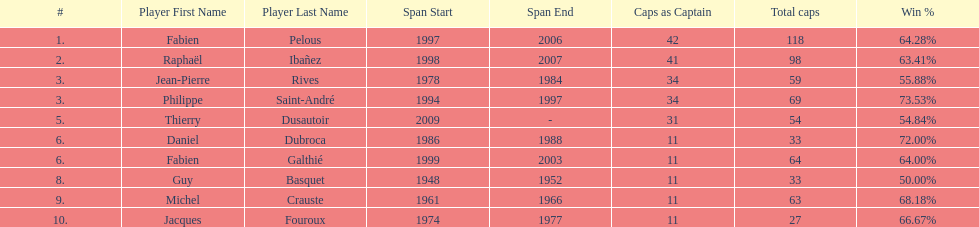How many caps did jean-pierre rives and michel crauste accrue? 122. 